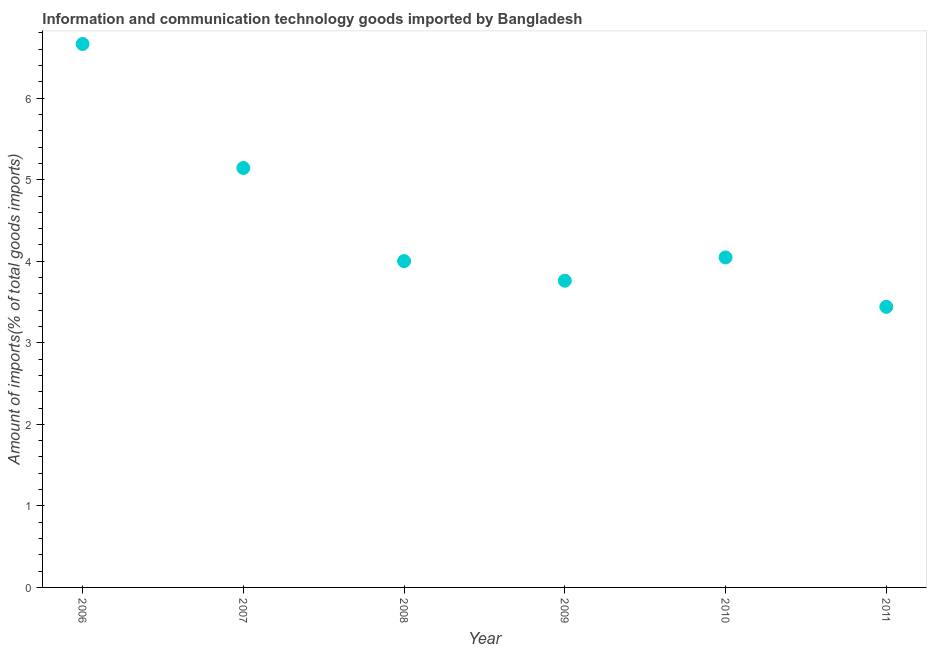What is the amount of ict goods imports in 2011?
Provide a succinct answer. 3.44. Across all years, what is the maximum amount of ict goods imports?
Your answer should be compact. 6.66. Across all years, what is the minimum amount of ict goods imports?
Your answer should be very brief. 3.44. In which year was the amount of ict goods imports maximum?
Your answer should be compact. 2006. In which year was the amount of ict goods imports minimum?
Your response must be concise. 2011. What is the sum of the amount of ict goods imports?
Ensure brevity in your answer.  27.06. What is the difference between the amount of ict goods imports in 2006 and 2008?
Your response must be concise. 2.66. What is the average amount of ict goods imports per year?
Offer a terse response. 4.51. What is the median amount of ict goods imports?
Provide a short and direct response. 4.02. In how many years, is the amount of ict goods imports greater than 0.2 %?
Your answer should be compact. 6. What is the ratio of the amount of ict goods imports in 2006 to that in 2008?
Keep it short and to the point. 1.67. Is the difference between the amount of ict goods imports in 2007 and 2008 greater than the difference between any two years?
Offer a terse response. No. What is the difference between the highest and the second highest amount of ict goods imports?
Offer a terse response. 1.52. Is the sum of the amount of ict goods imports in 2009 and 2010 greater than the maximum amount of ict goods imports across all years?
Offer a very short reply. Yes. What is the difference between the highest and the lowest amount of ict goods imports?
Ensure brevity in your answer.  3.22. How many dotlines are there?
Your answer should be compact. 1. How many years are there in the graph?
Give a very brief answer. 6. Does the graph contain any zero values?
Your answer should be very brief. No. Does the graph contain grids?
Provide a succinct answer. No. What is the title of the graph?
Offer a terse response. Information and communication technology goods imported by Bangladesh. What is the label or title of the X-axis?
Ensure brevity in your answer.  Year. What is the label or title of the Y-axis?
Provide a short and direct response. Amount of imports(% of total goods imports). What is the Amount of imports(% of total goods imports) in 2006?
Offer a very short reply. 6.66. What is the Amount of imports(% of total goods imports) in 2007?
Ensure brevity in your answer.  5.14. What is the Amount of imports(% of total goods imports) in 2008?
Provide a short and direct response. 4. What is the Amount of imports(% of total goods imports) in 2009?
Ensure brevity in your answer.  3.76. What is the Amount of imports(% of total goods imports) in 2010?
Give a very brief answer. 4.05. What is the Amount of imports(% of total goods imports) in 2011?
Offer a very short reply. 3.44. What is the difference between the Amount of imports(% of total goods imports) in 2006 and 2007?
Your response must be concise. 1.52. What is the difference between the Amount of imports(% of total goods imports) in 2006 and 2008?
Provide a succinct answer. 2.66. What is the difference between the Amount of imports(% of total goods imports) in 2006 and 2009?
Provide a short and direct response. 2.9. What is the difference between the Amount of imports(% of total goods imports) in 2006 and 2010?
Provide a succinct answer. 2.62. What is the difference between the Amount of imports(% of total goods imports) in 2006 and 2011?
Your answer should be very brief. 3.22. What is the difference between the Amount of imports(% of total goods imports) in 2007 and 2008?
Make the answer very short. 1.14. What is the difference between the Amount of imports(% of total goods imports) in 2007 and 2009?
Provide a short and direct response. 1.38. What is the difference between the Amount of imports(% of total goods imports) in 2007 and 2010?
Offer a terse response. 1.1. What is the difference between the Amount of imports(% of total goods imports) in 2007 and 2011?
Ensure brevity in your answer.  1.7. What is the difference between the Amount of imports(% of total goods imports) in 2008 and 2009?
Make the answer very short. 0.24. What is the difference between the Amount of imports(% of total goods imports) in 2008 and 2010?
Your response must be concise. -0.05. What is the difference between the Amount of imports(% of total goods imports) in 2008 and 2011?
Offer a very short reply. 0.56. What is the difference between the Amount of imports(% of total goods imports) in 2009 and 2010?
Provide a succinct answer. -0.29. What is the difference between the Amount of imports(% of total goods imports) in 2009 and 2011?
Your answer should be very brief. 0.32. What is the difference between the Amount of imports(% of total goods imports) in 2010 and 2011?
Your response must be concise. 0.61. What is the ratio of the Amount of imports(% of total goods imports) in 2006 to that in 2007?
Offer a very short reply. 1.3. What is the ratio of the Amount of imports(% of total goods imports) in 2006 to that in 2008?
Give a very brief answer. 1.67. What is the ratio of the Amount of imports(% of total goods imports) in 2006 to that in 2009?
Your answer should be very brief. 1.77. What is the ratio of the Amount of imports(% of total goods imports) in 2006 to that in 2010?
Offer a very short reply. 1.65. What is the ratio of the Amount of imports(% of total goods imports) in 2006 to that in 2011?
Ensure brevity in your answer.  1.94. What is the ratio of the Amount of imports(% of total goods imports) in 2007 to that in 2008?
Your answer should be very brief. 1.28. What is the ratio of the Amount of imports(% of total goods imports) in 2007 to that in 2009?
Provide a succinct answer. 1.37. What is the ratio of the Amount of imports(% of total goods imports) in 2007 to that in 2010?
Give a very brief answer. 1.27. What is the ratio of the Amount of imports(% of total goods imports) in 2007 to that in 2011?
Your answer should be compact. 1.5. What is the ratio of the Amount of imports(% of total goods imports) in 2008 to that in 2009?
Your answer should be compact. 1.06. What is the ratio of the Amount of imports(% of total goods imports) in 2008 to that in 2010?
Keep it short and to the point. 0.99. What is the ratio of the Amount of imports(% of total goods imports) in 2008 to that in 2011?
Give a very brief answer. 1.16. What is the ratio of the Amount of imports(% of total goods imports) in 2009 to that in 2010?
Make the answer very short. 0.93. What is the ratio of the Amount of imports(% of total goods imports) in 2009 to that in 2011?
Offer a terse response. 1.09. What is the ratio of the Amount of imports(% of total goods imports) in 2010 to that in 2011?
Offer a very short reply. 1.18. 